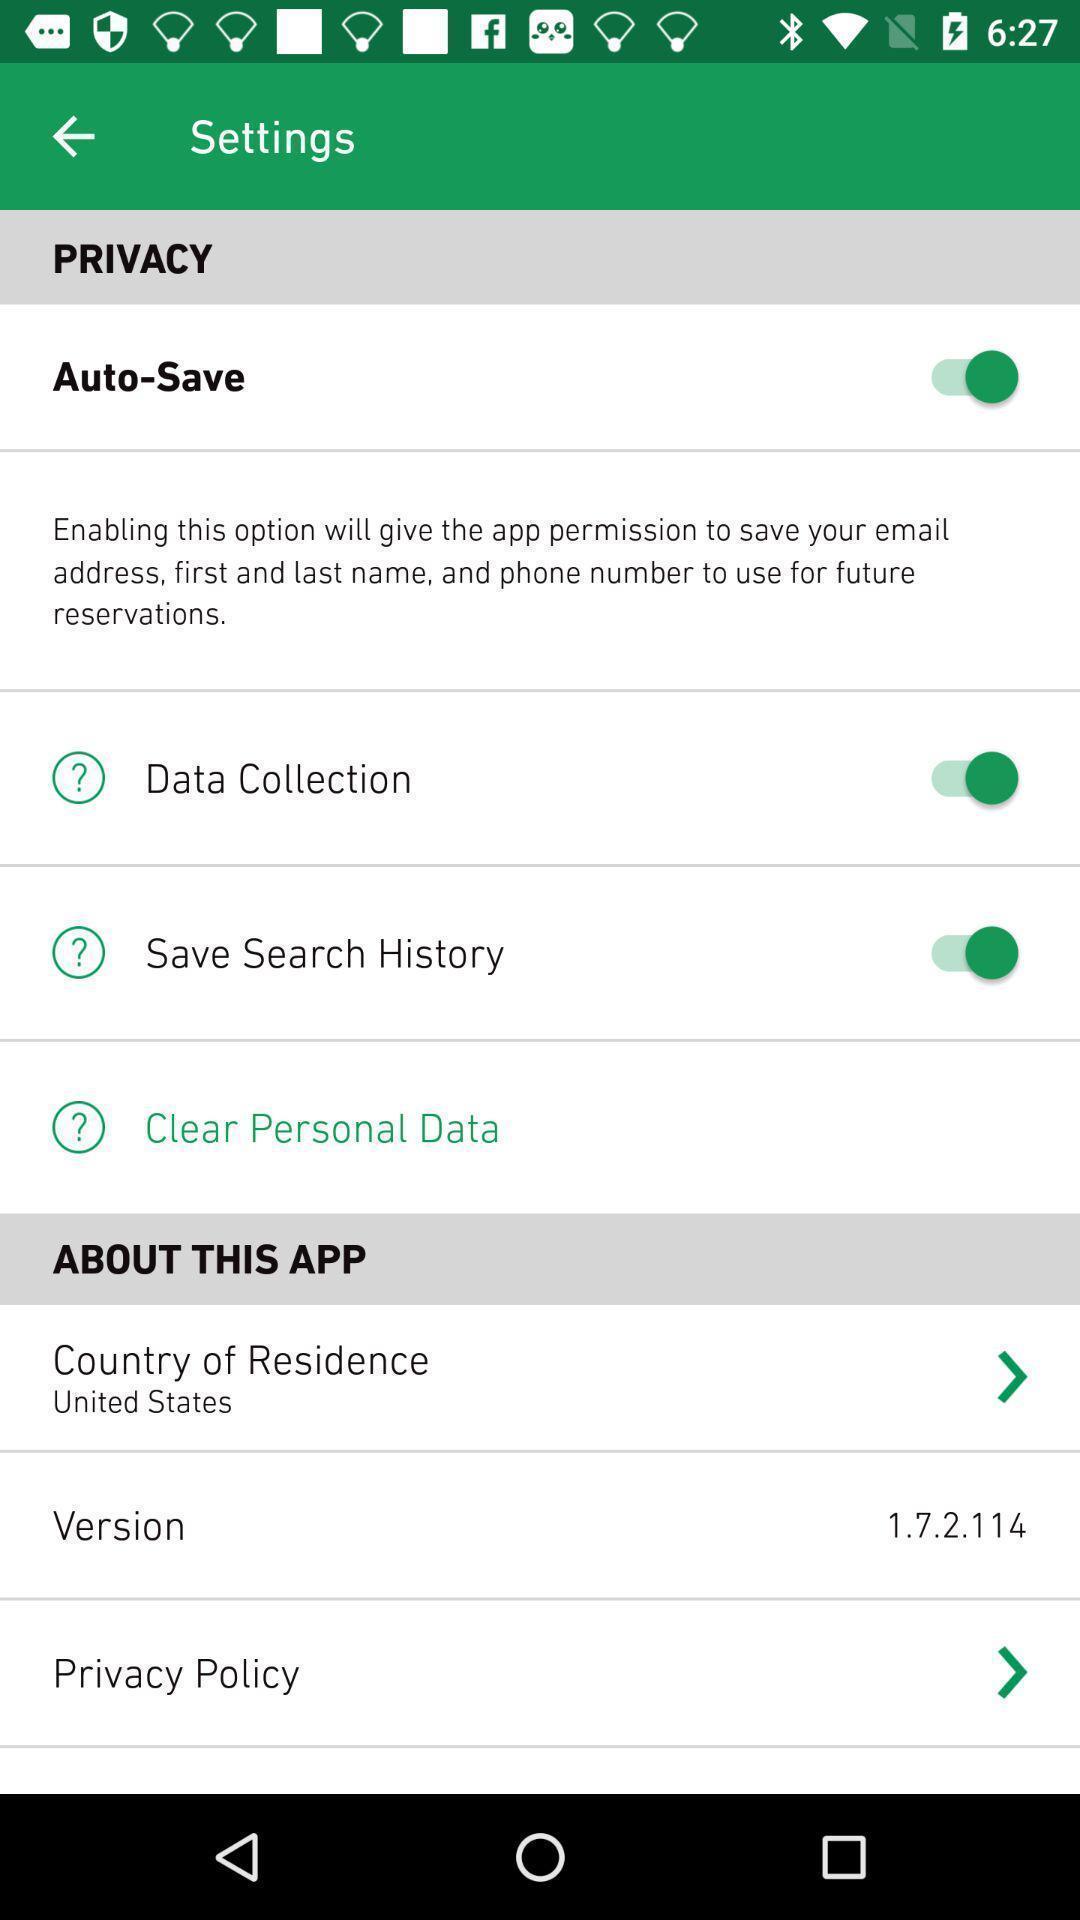Provide a detailed account of this screenshot. Page displaying the setting options. 